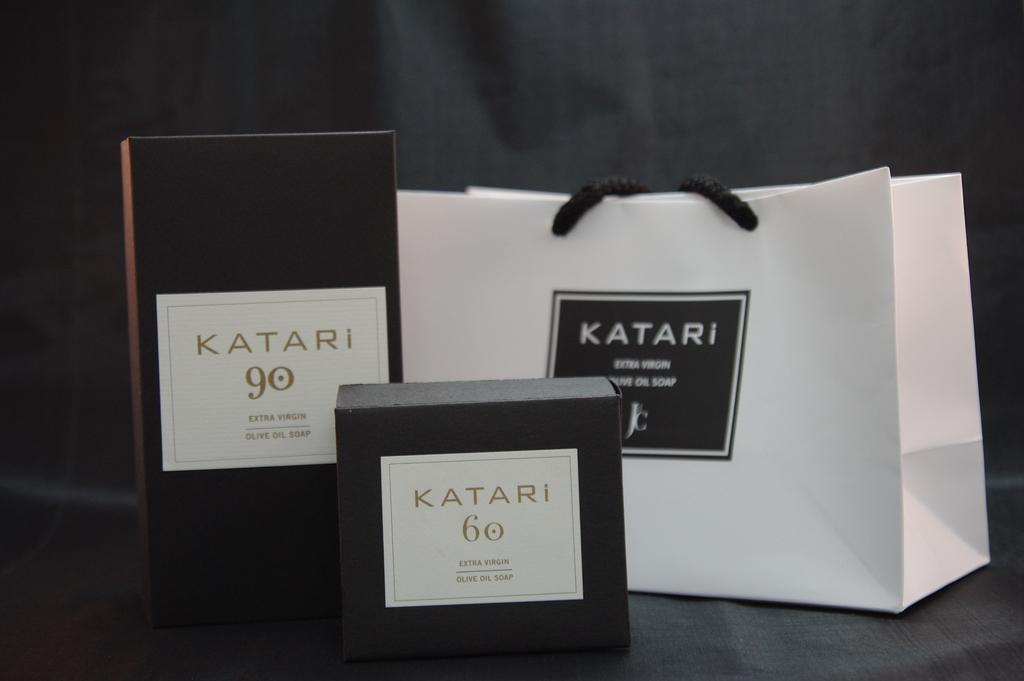<image>
Create a compact narrative representing the image presented. Katari brand olive oil soap containers and bag. 